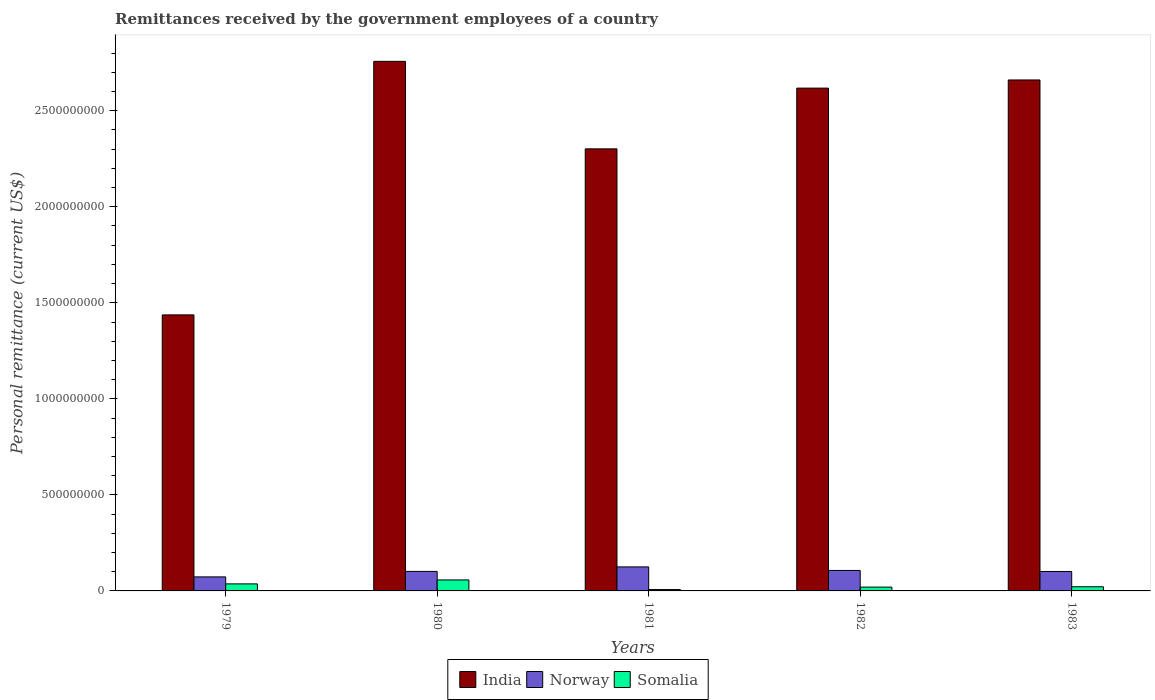Are the number of bars per tick equal to the number of legend labels?
Ensure brevity in your answer.  Yes. What is the label of the 1st group of bars from the left?
Offer a terse response. 1979. What is the remittances received by the government employees in Norway in 1981?
Offer a terse response. 1.25e+08. Across all years, what is the maximum remittances received by the government employees in Norway?
Offer a very short reply. 1.25e+08. Across all years, what is the minimum remittances received by the government employees in Somalia?
Your answer should be compact. 7.15e+06. In which year was the remittances received by the government employees in Somalia maximum?
Keep it short and to the point. 1980. In which year was the remittances received by the government employees in India minimum?
Give a very brief answer. 1979. What is the total remittances received by the government employees in India in the graph?
Keep it short and to the point. 1.18e+1. What is the difference between the remittances received by the government employees in India in 1980 and that in 1982?
Ensure brevity in your answer.  1.39e+08. What is the difference between the remittances received by the government employees in Norway in 1981 and the remittances received by the government employees in India in 1983?
Offer a terse response. -2.54e+09. What is the average remittances received by the government employees in Norway per year?
Make the answer very short. 1.02e+08. In the year 1981, what is the difference between the remittances received by the government employees in Norway and remittances received by the government employees in India?
Your answer should be very brief. -2.18e+09. In how many years, is the remittances received by the government employees in Somalia greater than 2000000000 US$?
Your answer should be compact. 0. What is the ratio of the remittances received by the government employees in India in 1981 to that in 1983?
Your response must be concise. 0.87. Is the difference between the remittances received by the government employees in Norway in 1979 and 1982 greater than the difference between the remittances received by the government employees in India in 1979 and 1982?
Provide a succinct answer. Yes. What is the difference between the highest and the second highest remittances received by the government employees in Somalia?
Make the answer very short. 2.06e+07. What is the difference between the highest and the lowest remittances received by the government employees in Norway?
Make the answer very short. 5.20e+07. Is the sum of the remittances received by the government employees in Norway in 1981 and 1983 greater than the maximum remittances received by the government employees in Somalia across all years?
Your response must be concise. Yes. How many bars are there?
Give a very brief answer. 15. Are all the bars in the graph horizontal?
Your answer should be compact. No. What is the difference between two consecutive major ticks on the Y-axis?
Keep it short and to the point. 5.00e+08. Does the graph contain any zero values?
Ensure brevity in your answer.  No. Does the graph contain grids?
Provide a succinct answer. No. Where does the legend appear in the graph?
Offer a very short reply. Bottom center. How many legend labels are there?
Give a very brief answer. 3. What is the title of the graph?
Keep it short and to the point. Remittances received by the government employees of a country. Does "Denmark" appear as one of the legend labels in the graph?
Your answer should be very brief. No. What is the label or title of the X-axis?
Give a very brief answer. Years. What is the label or title of the Y-axis?
Your answer should be very brief. Personal remittance (current US$). What is the Personal remittance (current US$) in India in 1979?
Ensure brevity in your answer.  1.44e+09. What is the Personal remittance (current US$) in Norway in 1979?
Ensure brevity in your answer.  7.31e+07. What is the Personal remittance (current US$) of Somalia in 1979?
Offer a terse response. 3.66e+07. What is the Personal remittance (current US$) of India in 1980?
Offer a terse response. 2.76e+09. What is the Personal remittance (current US$) of Norway in 1980?
Give a very brief answer. 1.02e+08. What is the Personal remittance (current US$) in Somalia in 1980?
Offer a terse response. 5.73e+07. What is the Personal remittance (current US$) of India in 1981?
Give a very brief answer. 2.30e+09. What is the Personal remittance (current US$) of Norway in 1981?
Make the answer very short. 1.25e+08. What is the Personal remittance (current US$) of Somalia in 1981?
Your answer should be very brief. 7.15e+06. What is the Personal remittance (current US$) in India in 1982?
Your response must be concise. 2.62e+09. What is the Personal remittance (current US$) of Norway in 1982?
Keep it short and to the point. 1.07e+08. What is the Personal remittance (current US$) of Somalia in 1982?
Your response must be concise. 1.99e+07. What is the Personal remittance (current US$) of India in 1983?
Keep it short and to the point. 2.66e+09. What is the Personal remittance (current US$) in Norway in 1983?
Give a very brief answer. 1.01e+08. What is the Personal remittance (current US$) of Somalia in 1983?
Provide a short and direct response. 2.17e+07. Across all years, what is the maximum Personal remittance (current US$) of India?
Your answer should be compact. 2.76e+09. Across all years, what is the maximum Personal remittance (current US$) of Norway?
Your answer should be very brief. 1.25e+08. Across all years, what is the maximum Personal remittance (current US$) in Somalia?
Provide a short and direct response. 5.73e+07. Across all years, what is the minimum Personal remittance (current US$) of India?
Provide a short and direct response. 1.44e+09. Across all years, what is the minimum Personal remittance (current US$) of Norway?
Offer a very short reply. 7.31e+07. Across all years, what is the minimum Personal remittance (current US$) of Somalia?
Keep it short and to the point. 7.15e+06. What is the total Personal remittance (current US$) in India in the graph?
Your answer should be very brief. 1.18e+1. What is the total Personal remittance (current US$) of Norway in the graph?
Offer a very short reply. 5.08e+08. What is the total Personal remittance (current US$) in Somalia in the graph?
Your answer should be compact. 1.43e+08. What is the difference between the Personal remittance (current US$) in India in 1979 and that in 1980?
Give a very brief answer. -1.32e+09. What is the difference between the Personal remittance (current US$) in Norway in 1979 and that in 1980?
Make the answer very short. -2.86e+07. What is the difference between the Personal remittance (current US$) in Somalia in 1979 and that in 1980?
Offer a very short reply. -2.06e+07. What is the difference between the Personal remittance (current US$) in India in 1979 and that in 1981?
Offer a very short reply. -8.64e+08. What is the difference between the Personal remittance (current US$) in Norway in 1979 and that in 1981?
Provide a short and direct response. -5.20e+07. What is the difference between the Personal remittance (current US$) of Somalia in 1979 and that in 1981?
Provide a short and direct response. 2.95e+07. What is the difference between the Personal remittance (current US$) in India in 1979 and that in 1982?
Offer a terse response. -1.18e+09. What is the difference between the Personal remittance (current US$) of Norway in 1979 and that in 1982?
Keep it short and to the point. -3.35e+07. What is the difference between the Personal remittance (current US$) of Somalia in 1979 and that in 1982?
Make the answer very short. 1.68e+07. What is the difference between the Personal remittance (current US$) of India in 1979 and that in 1983?
Make the answer very short. -1.22e+09. What is the difference between the Personal remittance (current US$) of Norway in 1979 and that in 1983?
Provide a succinct answer. -2.82e+07. What is the difference between the Personal remittance (current US$) in Somalia in 1979 and that in 1983?
Ensure brevity in your answer.  1.49e+07. What is the difference between the Personal remittance (current US$) of India in 1980 and that in 1981?
Make the answer very short. 4.56e+08. What is the difference between the Personal remittance (current US$) of Norway in 1980 and that in 1981?
Give a very brief answer. -2.34e+07. What is the difference between the Personal remittance (current US$) in Somalia in 1980 and that in 1981?
Offer a very short reply. 5.01e+07. What is the difference between the Personal remittance (current US$) of India in 1980 and that in 1982?
Offer a very short reply. 1.39e+08. What is the difference between the Personal remittance (current US$) in Norway in 1980 and that in 1982?
Your answer should be compact. -4.96e+06. What is the difference between the Personal remittance (current US$) in Somalia in 1980 and that in 1982?
Make the answer very short. 3.74e+07. What is the difference between the Personal remittance (current US$) of India in 1980 and that in 1983?
Provide a succinct answer. 9.69e+07. What is the difference between the Personal remittance (current US$) of Norway in 1980 and that in 1983?
Offer a terse response. 4.07e+05. What is the difference between the Personal remittance (current US$) in Somalia in 1980 and that in 1983?
Your answer should be compact. 3.56e+07. What is the difference between the Personal remittance (current US$) of India in 1981 and that in 1982?
Provide a succinct answer. -3.16e+08. What is the difference between the Personal remittance (current US$) in Norway in 1981 and that in 1982?
Ensure brevity in your answer.  1.84e+07. What is the difference between the Personal remittance (current US$) of Somalia in 1981 and that in 1982?
Make the answer very short. -1.27e+07. What is the difference between the Personal remittance (current US$) of India in 1981 and that in 1983?
Give a very brief answer. -3.59e+08. What is the difference between the Personal remittance (current US$) of Norway in 1981 and that in 1983?
Make the answer very short. 2.38e+07. What is the difference between the Personal remittance (current US$) in Somalia in 1981 and that in 1983?
Your answer should be very brief. -1.46e+07. What is the difference between the Personal remittance (current US$) in India in 1982 and that in 1983?
Your answer should be compact. -4.24e+07. What is the difference between the Personal remittance (current US$) in Norway in 1982 and that in 1983?
Your answer should be very brief. 5.37e+06. What is the difference between the Personal remittance (current US$) in Somalia in 1982 and that in 1983?
Offer a terse response. -1.80e+06. What is the difference between the Personal remittance (current US$) of India in 1979 and the Personal remittance (current US$) of Norway in 1980?
Provide a short and direct response. 1.34e+09. What is the difference between the Personal remittance (current US$) in India in 1979 and the Personal remittance (current US$) in Somalia in 1980?
Your answer should be very brief. 1.38e+09. What is the difference between the Personal remittance (current US$) in Norway in 1979 and the Personal remittance (current US$) in Somalia in 1980?
Ensure brevity in your answer.  1.58e+07. What is the difference between the Personal remittance (current US$) of India in 1979 and the Personal remittance (current US$) of Norway in 1981?
Keep it short and to the point. 1.31e+09. What is the difference between the Personal remittance (current US$) in India in 1979 and the Personal remittance (current US$) in Somalia in 1981?
Provide a succinct answer. 1.43e+09. What is the difference between the Personal remittance (current US$) of Norway in 1979 and the Personal remittance (current US$) of Somalia in 1981?
Ensure brevity in your answer.  6.59e+07. What is the difference between the Personal remittance (current US$) in India in 1979 and the Personal remittance (current US$) in Norway in 1982?
Provide a succinct answer. 1.33e+09. What is the difference between the Personal remittance (current US$) of India in 1979 and the Personal remittance (current US$) of Somalia in 1982?
Keep it short and to the point. 1.42e+09. What is the difference between the Personal remittance (current US$) of Norway in 1979 and the Personal remittance (current US$) of Somalia in 1982?
Your response must be concise. 5.32e+07. What is the difference between the Personal remittance (current US$) in India in 1979 and the Personal remittance (current US$) in Norway in 1983?
Offer a terse response. 1.34e+09. What is the difference between the Personal remittance (current US$) in India in 1979 and the Personal remittance (current US$) in Somalia in 1983?
Provide a succinct answer. 1.42e+09. What is the difference between the Personal remittance (current US$) of Norway in 1979 and the Personal remittance (current US$) of Somalia in 1983?
Provide a short and direct response. 5.14e+07. What is the difference between the Personal remittance (current US$) of India in 1980 and the Personal remittance (current US$) of Norway in 1981?
Your response must be concise. 2.63e+09. What is the difference between the Personal remittance (current US$) in India in 1980 and the Personal remittance (current US$) in Somalia in 1981?
Make the answer very short. 2.75e+09. What is the difference between the Personal remittance (current US$) of Norway in 1980 and the Personal remittance (current US$) of Somalia in 1981?
Your response must be concise. 9.45e+07. What is the difference between the Personal remittance (current US$) of India in 1980 and the Personal remittance (current US$) of Norway in 1982?
Provide a short and direct response. 2.65e+09. What is the difference between the Personal remittance (current US$) in India in 1980 and the Personal remittance (current US$) in Somalia in 1982?
Make the answer very short. 2.74e+09. What is the difference between the Personal remittance (current US$) of Norway in 1980 and the Personal remittance (current US$) of Somalia in 1982?
Keep it short and to the point. 8.17e+07. What is the difference between the Personal remittance (current US$) in India in 1980 and the Personal remittance (current US$) in Norway in 1983?
Give a very brief answer. 2.66e+09. What is the difference between the Personal remittance (current US$) in India in 1980 and the Personal remittance (current US$) in Somalia in 1983?
Your answer should be very brief. 2.74e+09. What is the difference between the Personal remittance (current US$) in Norway in 1980 and the Personal remittance (current US$) in Somalia in 1983?
Provide a succinct answer. 7.99e+07. What is the difference between the Personal remittance (current US$) in India in 1981 and the Personal remittance (current US$) in Norway in 1982?
Your response must be concise. 2.19e+09. What is the difference between the Personal remittance (current US$) of India in 1981 and the Personal remittance (current US$) of Somalia in 1982?
Your answer should be very brief. 2.28e+09. What is the difference between the Personal remittance (current US$) in Norway in 1981 and the Personal remittance (current US$) in Somalia in 1982?
Your answer should be very brief. 1.05e+08. What is the difference between the Personal remittance (current US$) in India in 1981 and the Personal remittance (current US$) in Norway in 1983?
Provide a short and direct response. 2.20e+09. What is the difference between the Personal remittance (current US$) of India in 1981 and the Personal remittance (current US$) of Somalia in 1983?
Provide a short and direct response. 2.28e+09. What is the difference between the Personal remittance (current US$) of Norway in 1981 and the Personal remittance (current US$) of Somalia in 1983?
Make the answer very short. 1.03e+08. What is the difference between the Personal remittance (current US$) of India in 1982 and the Personal remittance (current US$) of Norway in 1983?
Your answer should be very brief. 2.52e+09. What is the difference between the Personal remittance (current US$) in India in 1982 and the Personal remittance (current US$) in Somalia in 1983?
Make the answer very short. 2.60e+09. What is the difference between the Personal remittance (current US$) of Norway in 1982 and the Personal remittance (current US$) of Somalia in 1983?
Your response must be concise. 8.49e+07. What is the average Personal remittance (current US$) of India per year?
Provide a short and direct response. 2.35e+09. What is the average Personal remittance (current US$) of Norway per year?
Your answer should be very brief. 1.02e+08. What is the average Personal remittance (current US$) of Somalia per year?
Make the answer very short. 2.85e+07. In the year 1979, what is the difference between the Personal remittance (current US$) of India and Personal remittance (current US$) of Norway?
Provide a short and direct response. 1.36e+09. In the year 1979, what is the difference between the Personal remittance (current US$) in India and Personal remittance (current US$) in Somalia?
Offer a very short reply. 1.40e+09. In the year 1979, what is the difference between the Personal remittance (current US$) of Norway and Personal remittance (current US$) of Somalia?
Offer a very short reply. 3.64e+07. In the year 1980, what is the difference between the Personal remittance (current US$) of India and Personal remittance (current US$) of Norway?
Give a very brief answer. 2.66e+09. In the year 1980, what is the difference between the Personal remittance (current US$) in India and Personal remittance (current US$) in Somalia?
Ensure brevity in your answer.  2.70e+09. In the year 1980, what is the difference between the Personal remittance (current US$) of Norway and Personal remittance (current US$) of Somalia?
Keep it short and to the point. 4.44e+07. In the year 1981, what is the difference between the Personal remittance (current US$) in India and Personal remittance (current US$) in Norway?
Keep it short and to the point. 2.18e+09. In the year 1981, what is the difference between the Personal remittance (current US$) of India and Personal remittance (current US$) of Somalia?
Keep it short and to the point. 2.29e+09. In the year 1981, what is the difference between the Personal remittance (current US$) of Norway and Personal remittance (current US$) of Somalia?
Provide a short and direct response. 1.18e+08. In the year 1982, what is the difference between the Personal remittance (current US$) of India and Personal remittance (current US$) of Norway?
Offer a very short reply. 2.51e+09. In the year 1982, what is the difference between the Personal remittance (current US$) of India and Personal remittance (current US$) of Somalia?
Offer a terse response. 2.60e+09. In the year 1982, what is the difference between the Personal remittance (current US$) of Norway and Personal remittance (current US$) of Somalia?
Ensure brevity in your answer.  8.67e+07. In the year 1983, what is the difference between the Personal remittance (current US$) of India and Personal remittance (current US$) of Norway?
Provide a succinct answer. 2.56e+09. In the year 1983, what is the difference between the Personal remittance (current US$) in India and Personal remittance (current US$) in Somalia?
Provide a short and direct response. 2.64e+09. In the year 1983, what is the difference between the Personal remittance (current US$) in Norway and Personal remittance (current US$) in Somalia?
Provide a succinct answer. 7.95e+07. What is the ratio of the Personal remittance (current US$) of India in 1979 to that in 1980?
Offer a terse response. 0.52. What is the ratio of the Personal remittance (current US$) of Norway in 1979 to that in 1980?
Make the answer very short. 0.72. What is the ratio of the Personal remittance (current US$) in Somalia in 1979 to that in 1980?
Your answer should be compact. 0.64. What is the ratio of the Personal remittance (current US$) in India in 1979 to that in 1981?
Make the answer very short. 0.62. What is the ratio of the Personal remittance (current US$) in Norway in 1979 to that in 1981?
Make the answer very short. 0.58. What is the ratio of the Personal remittance (current US$) of Somalia in 1979 to that in 1981?
Your response must be concise. 5.13. What is the ratio of the Personal remittance (current US$) in India in 1979 to that in 1982?
Offer a very short reply. 0.55. What is the ratio of the Personal remittance (current US$) in Norway in 1979 to that in 1982?
Give a very brief answer. 0.69. What is the ratio of the Personal remittance (current US$) in Somalia in 1979 to that in 1982?
Ensure brevity in your answer.  1.84. What is the ratio of the Personal remittance (current US$) in India in 1979 to that in 1983?
Provide a succinct answer. 0.54. What is the ratio of the Personal remittance (current US$) in Norway in 1979 to that in 1983?
Offer a terse response. 0.72. What is the ratio of the Personal remittance (current US$) of Somalia in 1979 to that in 1983?
Provide a short and direct response. 1.69. What is the ratio of the Personal remittance (current US$) in India in 1980 to that in 1981?
Ensure brevity in your answer.  1.2. What is the ratio of the Personal remittance (current US$) of Norway in 1980 to that in 1981?
Your answer should be very brief. 0.81. What is the ratio of the Personal remittance (current US$) in Somalia in 1980 to that in 1981?
Your response must be concise. 8.01. What is the ratio of the Personal remittance (current US$) in India in 1980 to that in 1982?
Give a very brief answer. 1.05. What is the ratio of the Personal remittance (current US$) of Norway in 1980 to that in 1982?
Your answer should be very brief. 0.95. What is the ratio of the Personal remittance (current US$) in Somalia in 1980 to that in 1982?
Make the answer very short. 2.88. What is the ratio of the Personal remittance (current US$) in India in 1980 to that in 1983?
Keep it short and to the point. 1.04. What is the ratio of the Personal remittance (current US$) in Norway in 1980 to that in 1983?
Provide a short and direct response. 1. What is the ratio of the Personal remittance (current US$) in Somalia in 1980 to that in 1983?
Your answer should be very brief. 2.64. What is the ratio of the Personal remittance (current US$) in India in 1981 to that in 1982?
Give a very brief answer. 0.88. What is the ratio of the Personal remittance (current US$) in Norway in 1981 to that in 1982?
Your answer should be very brief. 1.17. What is the ratio of the Personal remittance (current US$) of Somalia in 1981 to that in 1982?
Your answer should be compact. 0.36. What is the ratio of the Personal remittance (current US$) of India in 1981 to that in 1983?
Offer a very short reply. 0.87. What is the ratio of the Personal remittance (current US$) in Norway in 1981 to that in 1983?
Your response must be concise. 1.24. What is the ratio of the Personal remittance (current US$) of Somalia in 1981 to that in 1983?
Your response must be concise. 0.33. What is the ratio of the Personal remittance (current US$) of India in 1982 to that in 1983?
Provide a succinct answer. 0.98. What is the ratio of the Personal remittance (current US$) in Norway in 1982 to that in 1983?
Offer a terse response. 1.05. What is the ratio of the Personal remittance (current US$) of Somalia in 1982 to that in 1983?
Your answer should be very brief. 0.92. What is the difference between the highest and the second highest Personal remittance (current US$) in India?
Make the answer very short. 9.69e+07. What is the difference between the highest and the second highest Personal remittance (current US$) in Norway?
Your response must be concise. 1.84e+07. What is the difference between the highest and the second highest Personal remittance (current US$) of Somalia?
Provide a short and direct response. 2.06e+07. What is the difference between the highest and the lowest Personal remittance (current US$) in India?
Provide a succinct answer. 1.32e+09. What is the difference between the highest and the lowest Personal remittance (current US$) of Norway?
Keep it short and to the point. 5.20e+07. What is the difference between the highest and the lowest Personal remittance (current US$) of Somalia?
Your response must be concise. 5.01e+07. 